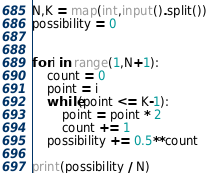Convert code to text. <code><loc_0><loc_0><loc_500><loc_500><_Python_>N,K = map(int,input().split())
possibility = 0


for i in range(1,N+1):
    count = 0
    point = i
    while(point <= K-1):
        point = point * 2
        count += 1
    possibility += 0.5**count

print(possibility / N)</code> 